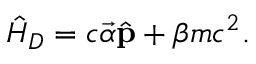<formula> <loc_0><loc_0><loc_500><loc_500>\hat { H } _ { D } = c \vec { \alpha } \hat { p } + \beta m c ^ { 2 } .</formula> 